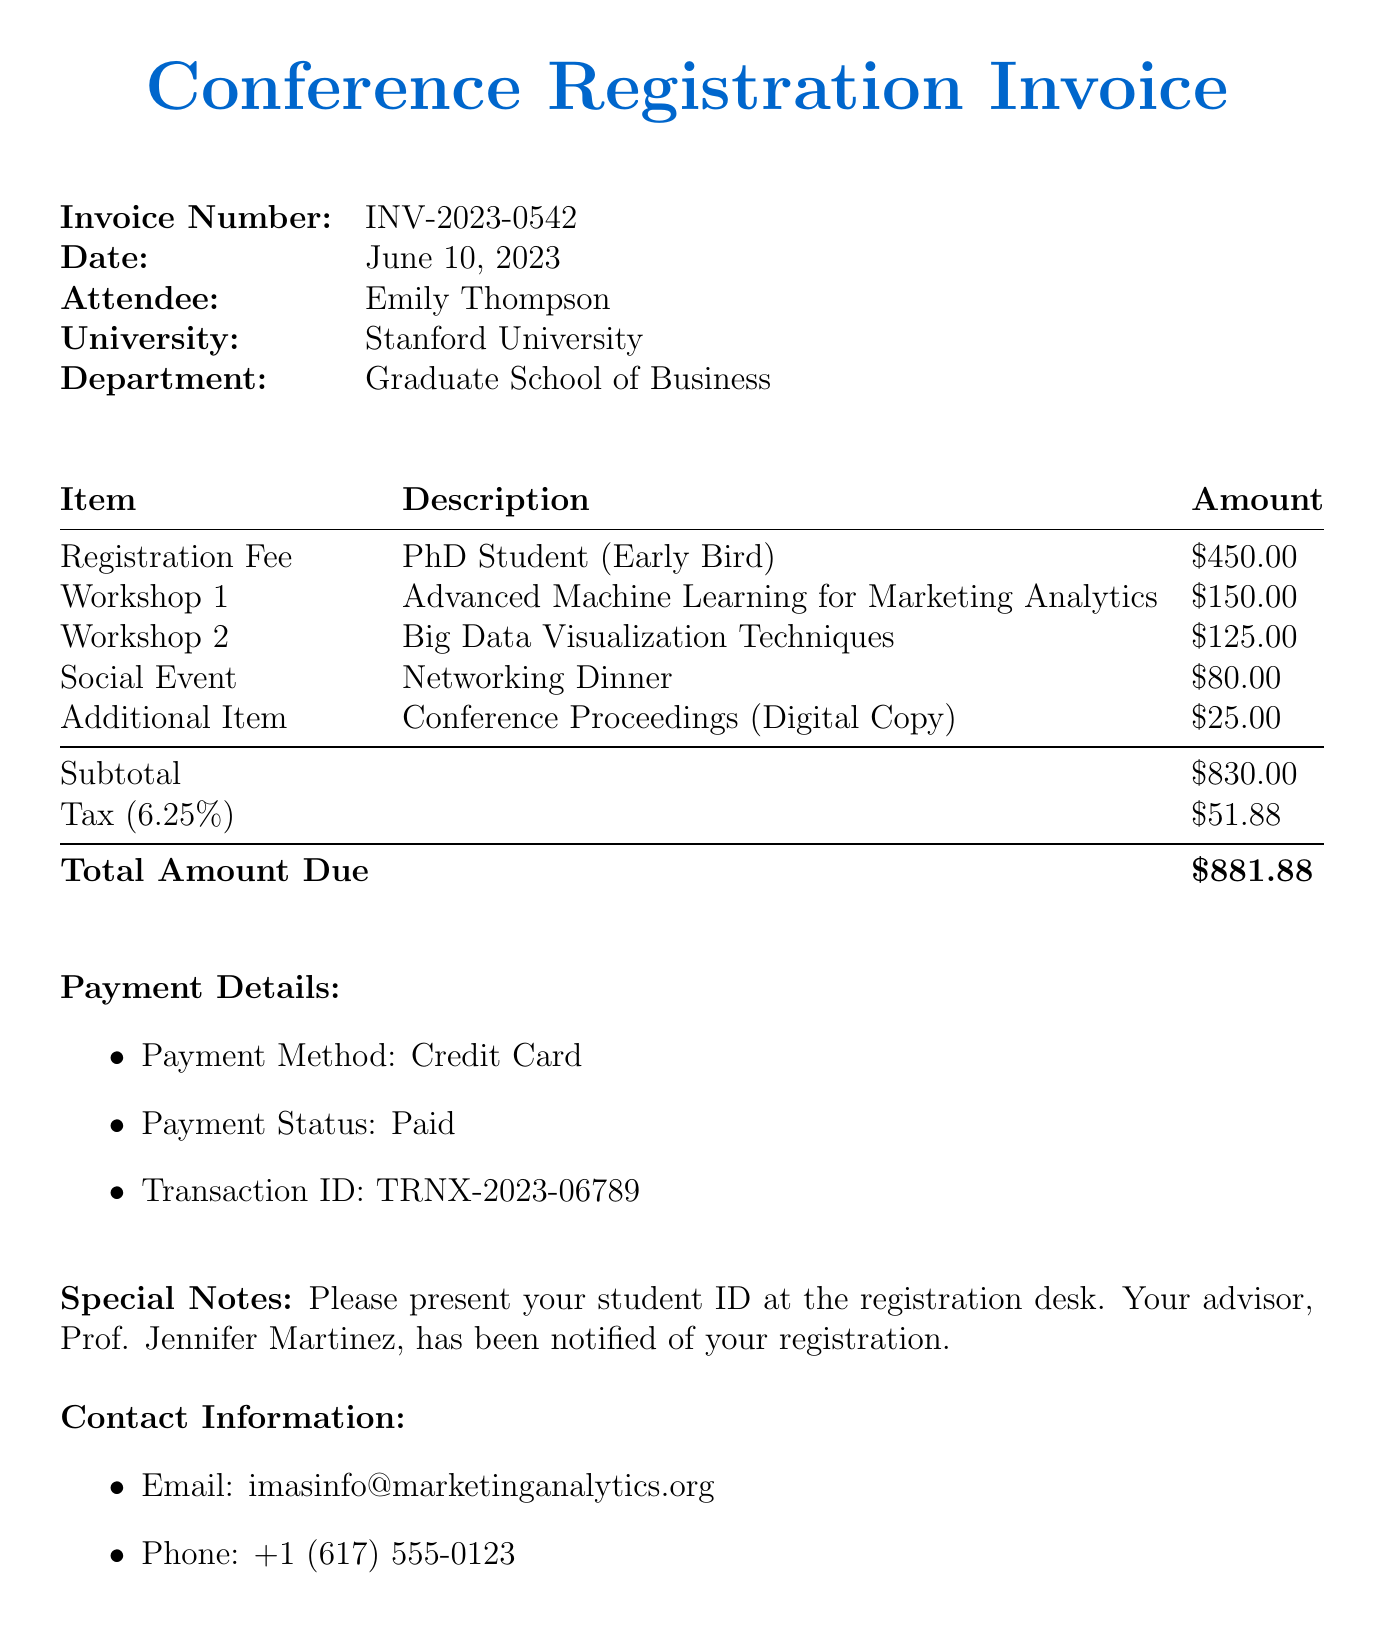What is the invoice number? The invoice number is a unique identifier provided at the top of the invoice document.
Answer: INV-2023-0542 What is the name of the conference? The name of the conference is printed prominently in the document, indicating the event attended.
Answer: International Marketing Analytics Symposium 2023 What is the early bird registration discount amount? The early bird discount amount is specified in the invoice, indicating the reduction in registration fees.
Answer: 100 What is the total amount due? The total amount due is calculated from the subtotal and tax and is highlighted at the bottom of the invoice.
Answer: 881.88 How much is the fee for the "Advanced Machine Learning for Marketing Analytics" workshop? This fee is listed under the workshop section, denoting the cost of attending that specific workshop.
Answer: 150 What date does the conference take place? The conference date is noted in the document, providing essential scheduling information.
Answer: September 15-17, 2023 How many workshops did Emily Thompson register for? This information requires counting the number of workshops listed in the invoice.
Answer: 2 What is the tax rate applied to the registration fees? The tax rate is stated in the invoice and is important for calculating the total amount.
Answer: 6.25% What payment method was used for the registration? The payment method is specified in the payment details section of the invoice.
Answer: Credit Card 